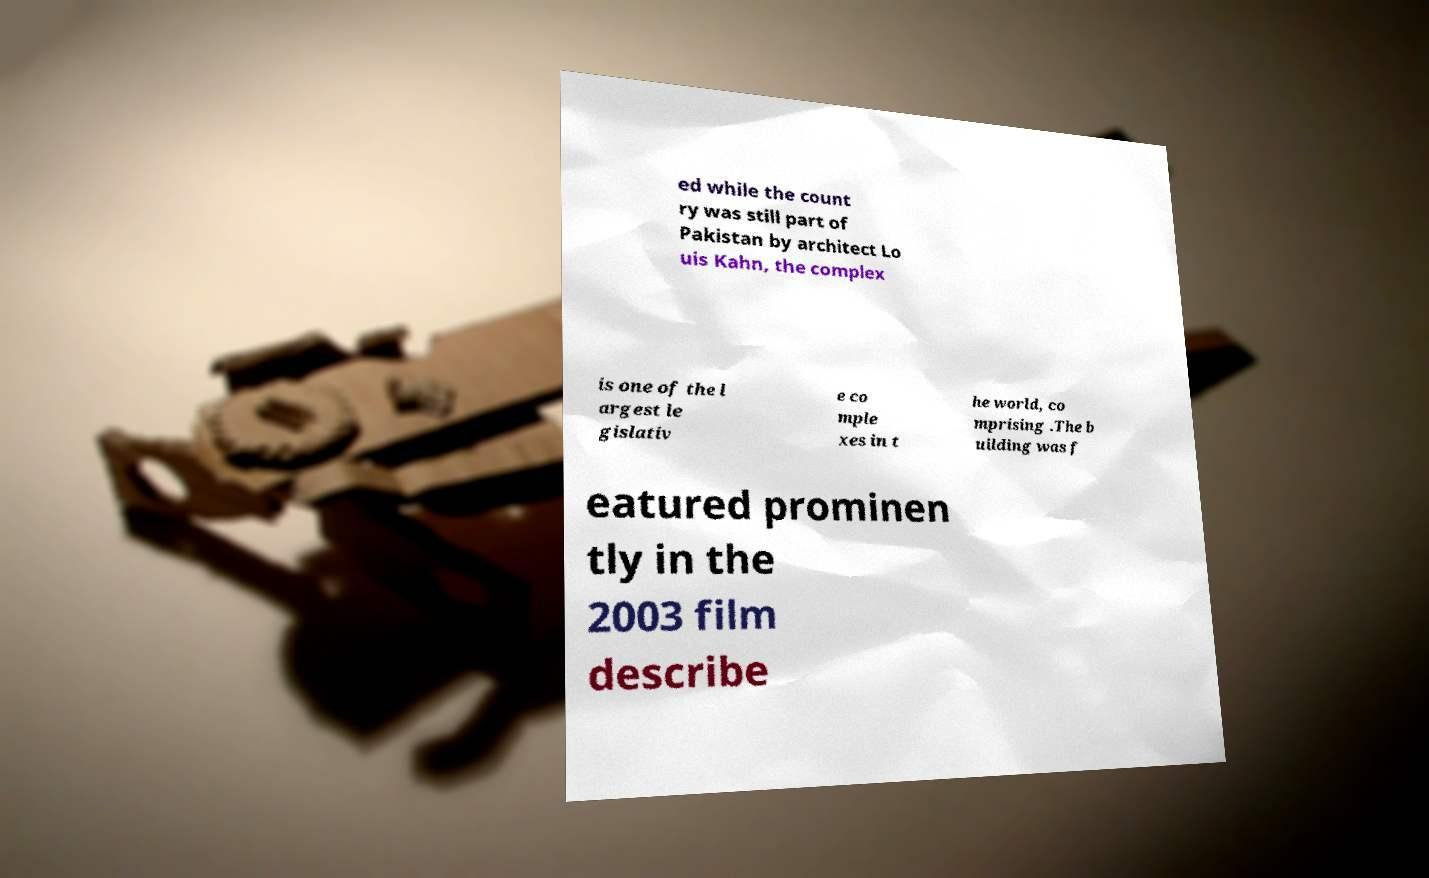Can you read and provide the text displayed in the image?This photo seems to have some interesting text. Can you extract and type it out for me? ed while the count ry was still part of Pakistan by architect Lo uis Kahn, the complex is one of the l argest le gislativ e co mple xes in t he world, co mprising .The b uilding was f eatured prominen tly in the 2003 film describe 